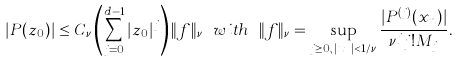Convert formula to latex. <formula><loc_0><loc_0><loc_500><loc_500>| P ( z _ { 0 } ) | \leq C _ { \nu } \left ( \sum _ { j = 0 } ^ { d - 1 } | z _ { 0 } | ^ { j } \right ) \| f \| _ { \nu } \ w i t h \ \| f \| _ { \nu } = \sup _ { j \geq 0 , \, | x _ { n } | < 1 / \nu } \frac { | P ^ { ( j ) } ( x _ { n } ) | } { \nu ^ { j } j ! M _ { j } } .</formula> 